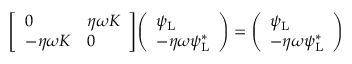<formula> <loc_0><loc_0><loc_500><loc_500>{ \left [ \begin{array} { l l } { 0 } & { \eta \omega K } \\ { - \eta \omega K } & { 0 } \end{array} \right ] } { \left ( \begin{array} { l } { \psi _ { L } } \\ { - \eta \omega \psi _ { L } ^ { * } } \end{array} \right ) } = { \left ( \begin{array} { l } { \psi _ { L } } \\ { - \eta \omega \psi _ { L } ^ { * } } \end{array} \right ) }</formula> 